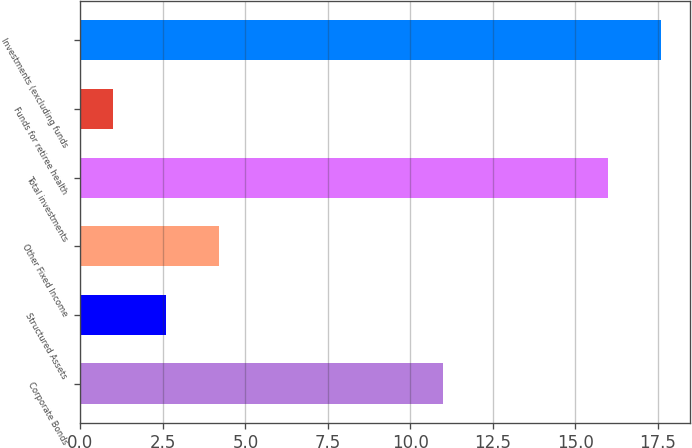Convert chart. <chart><loc_0><loc_0><loc_500><loc_500><bar_chart><fcel>Corporate Bonds<fcel>Structured Assets<fcel>Other Fixed Income<fcel>Total investments<fcel>Funds for retiree health<fcel>Investments (excluding funds<nl><fcel>11<fcel>2.6<fcel>4.2<fcel>16<fcel>1<fcel>17.6<nl></chart> 